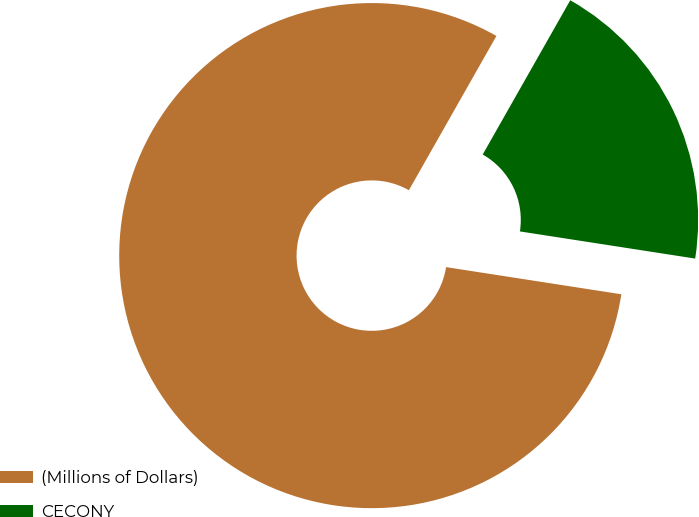<chart> <loc_0><loc_0><loc_500><loc_500><pie_chart><fcel>(Millions of Dollars)<fcel>CECONY<nl><fcel>80.77%<fcel>19.23%<nl></chart> 